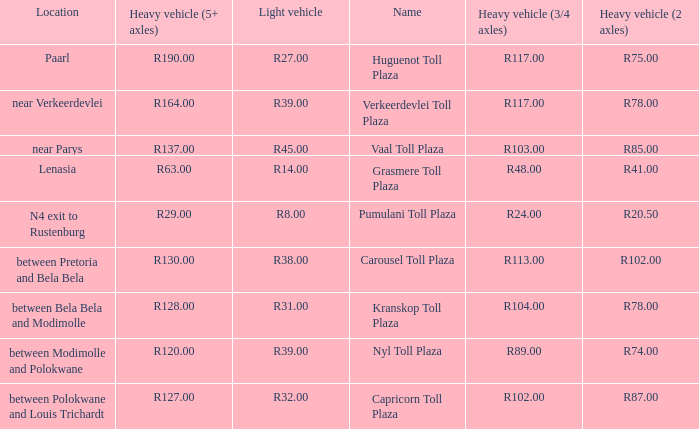What is the toll for light vehicles at the plaza where the toll for heavy vehicles with 2 axles is r87.00? R32.00. 